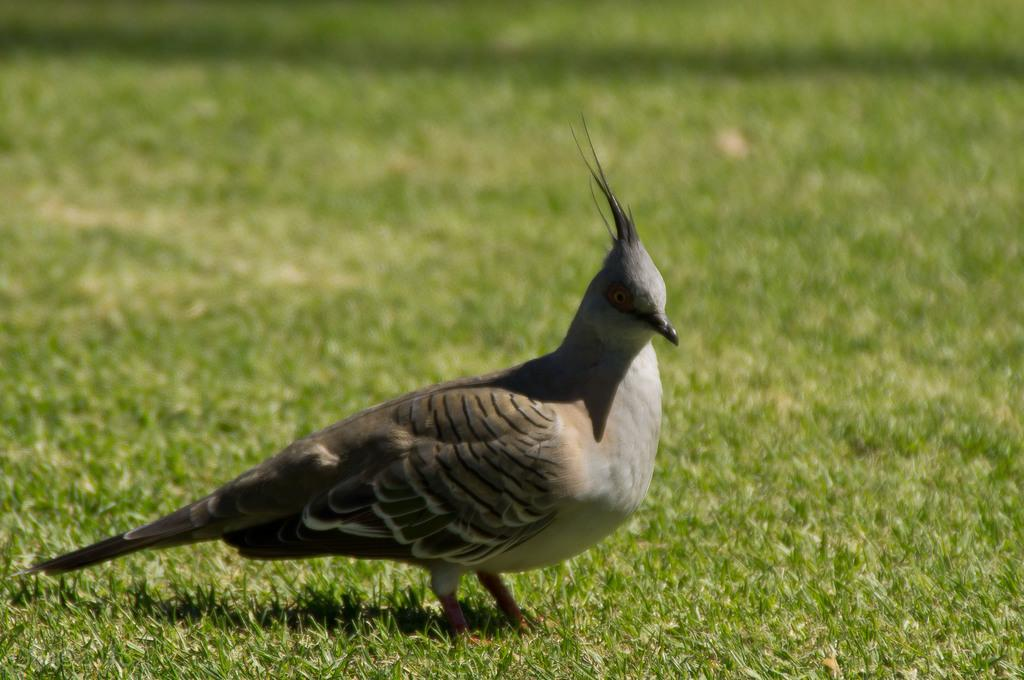What type of animal is present in the image? There is a bird in the image. Where is the bird located in the image? The bird is standing on the ground. What type of van can be seen driving through the bird in the image? There is no van present in the image, and the bird is not being driven through by any vehicle. 